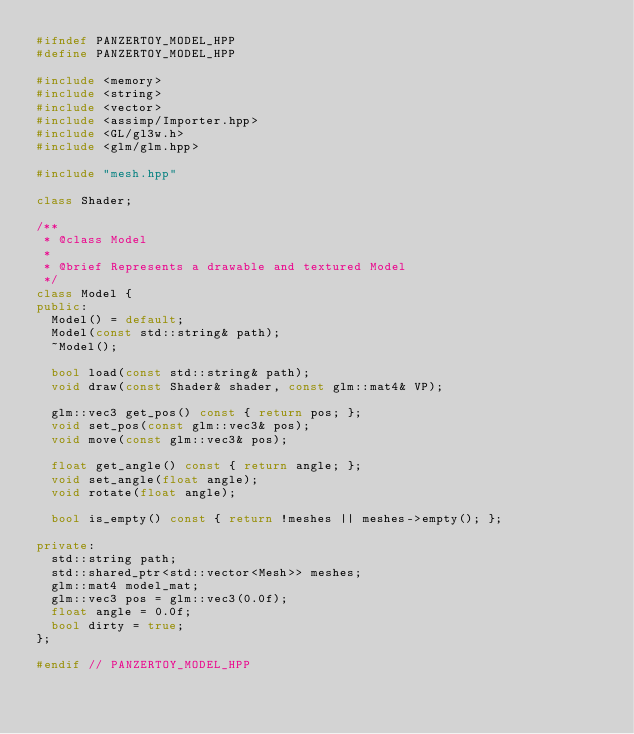<code> <loc_0><loc_0><loc_500><loc_500><_C++_>#ifndef PANZERTOY_MODEL_HPP
#define PANZERTOY_MODEL_HPP

#include <memory>
#include <string>
#include <vector>
#include <assimp/Importer.hpp>
#include <GL/gl3w.h>
#include <glm/glm.hpp>

#include "mesh.hpp"

class Shader;

/**
 * @class Model
 *
 * @brief Represents a drawable and textured Model
 */
class Model {
public:
	Model() = default;
	Model(const std::string& path);
	~Model();

	bool load(const std::string& path);
	void draw(const Shader& shader, const glm::mat4& VP);

	glm::vec3 get_pos() const { return pos; };
	void set_pos(const glm::vec3& pos);
	void move(const glm::vec3& pos);

	float get_angle() const { return angle; };
	void set_angle(float angle);
	void rotate(float angle);

	bool is_empty() const { return !meshes || meshes->empty(); };

private:
	std::string path;
	std::shared_ptr<std::vector<Mesh>> meshes;
	glm::mat4 model_mat;
	glm::vec3 pos = glm::vec3(0.0f);
	float angle = 0.0f;
	bool dirty = true;
};

#endif // PANZERTOY_MODEL_HPP
</code> 